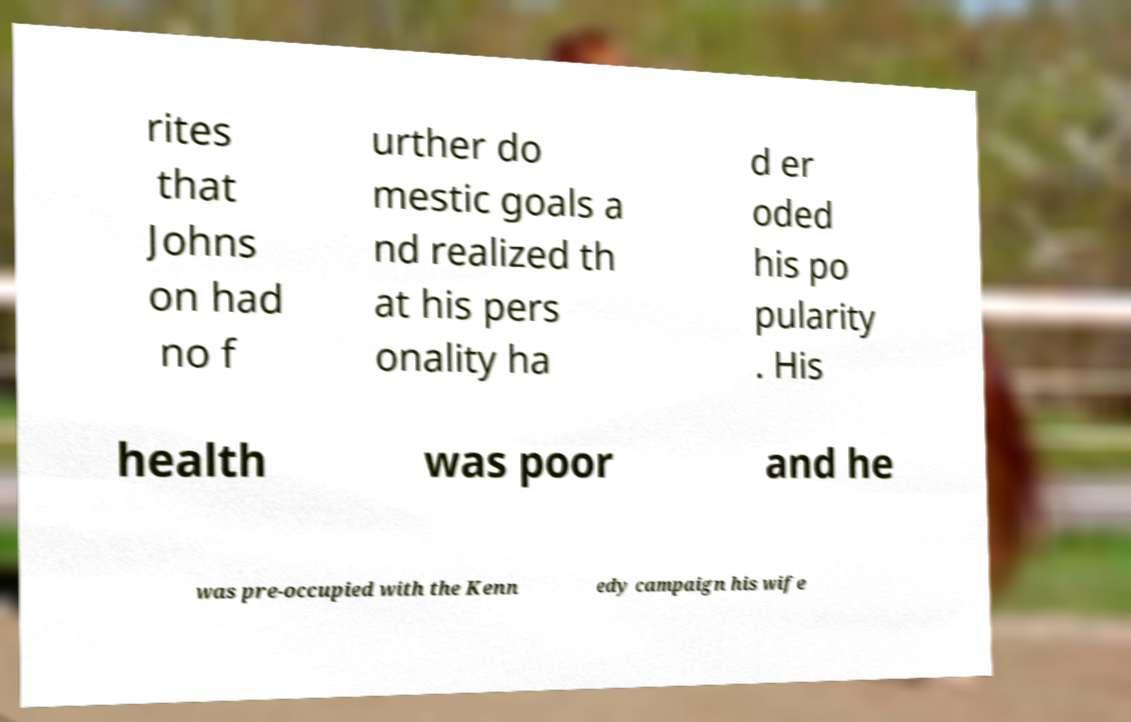Can you accurately transcribe the text from the provided image for me? rites that Johns on had no f urther do mestic goals a nd realized th at his pers onality ha d er oded his po pularity . His health was poor and he was pre-occupied with the Kenn edy campaign his wife 